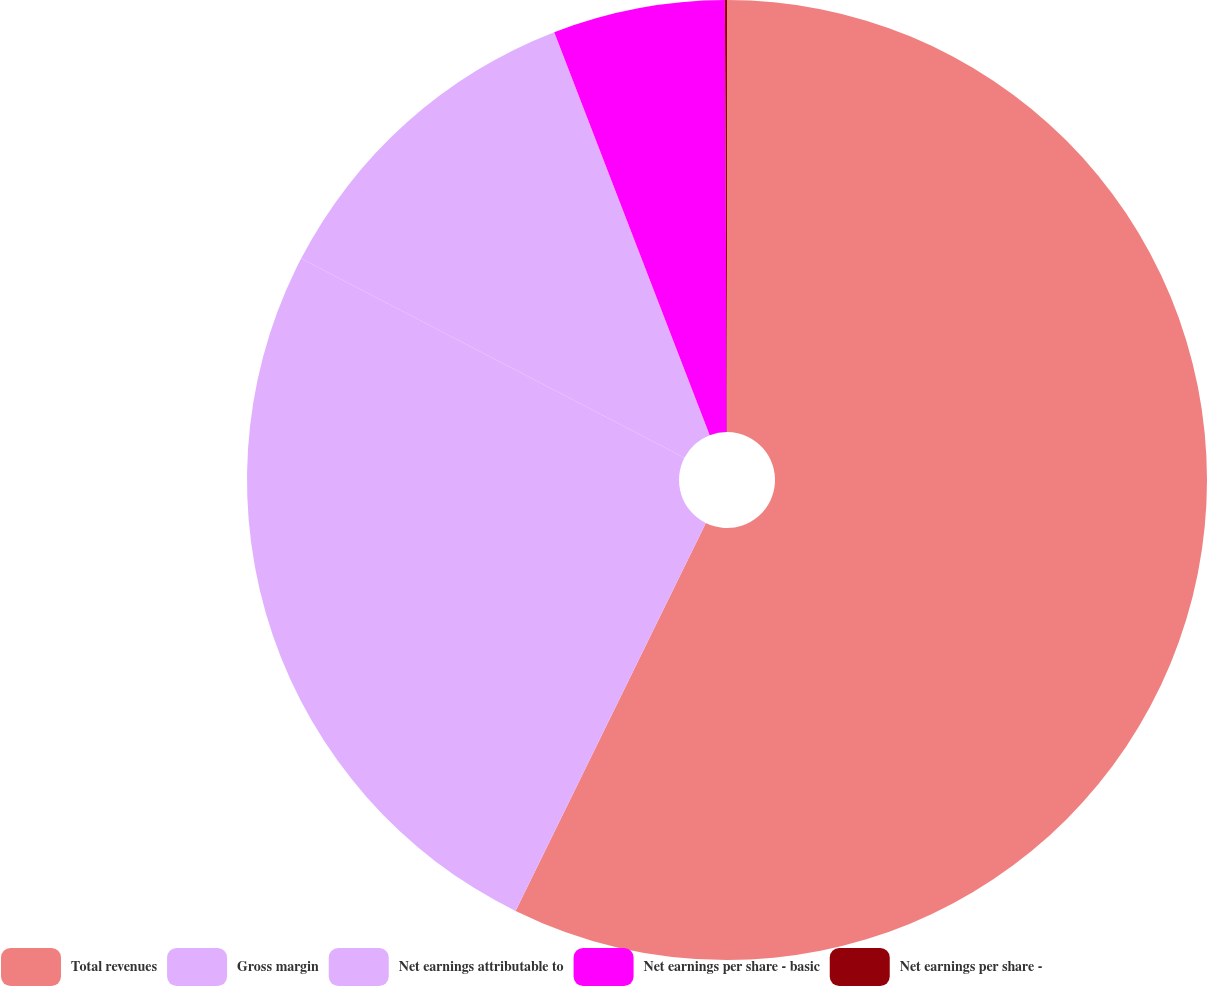Convert chart. <chart><loc_0><loc_0><loc_500><loc_500><pie_chart><fcel>Total revenues<fcel>Gross margin<fcel>Net earnings attributable to<fcel>Net earnings per share - basic<fcel>Net earnings per share -<nl><fcel>57.26%<fcel>25.37%<fcel>11.51%<fcel>5.79%<fcel>0.07%<nl></chart> 